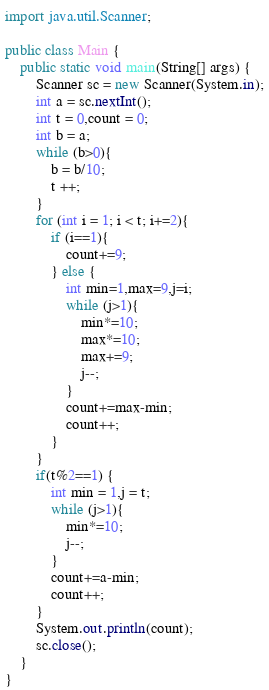Convert code to text. <code><loc_0><loc_0><loc_500><loc_500><_Java_>import java.util.Scanner;

public class Main {
	public static void main(String[] args) {
		Scanner sc = new Scanner(System.in);
		int a = sc.nextInt();
		int t = 0,count = 0;
		int b = a;
		while (b>0){
			b = b/10;
			t ++;
		}
		for (int i = 1; i < t; i+=2){
			if (i==1){
				count+=9;
			} else {
				int min=1,max=9,j=i;
				while (j>1){
					min*=10;
					max*=10;
					max+=9;
					j--;
				}
				count+=max-min;
				count++;
			}
		}
		if(t%2==1) {
			int min = 1,j = t;
			while (j>1){
				min*=10;
				j--;
			}
			count+=a-min;
			count++;
		}
		System.out.println(count);
		sc.close();
	}
}</code> 